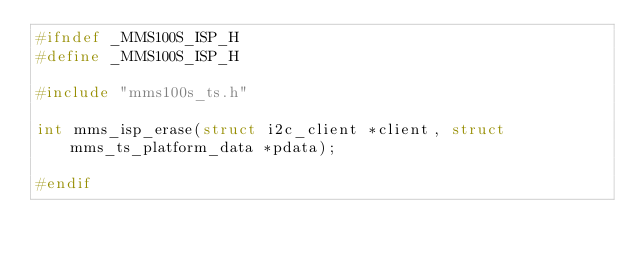<code> <loc_0><loc_0><loc_500><loc_500><_C_>#ifndef _MMS100S_ISP_H
#define _MMS100S_ISP_H

#include "mms100s_ts.h"

int mms_isp_erase(struct i2c_client *client, struct mms_ts_platform_data *pdata);

#endif

</code> 